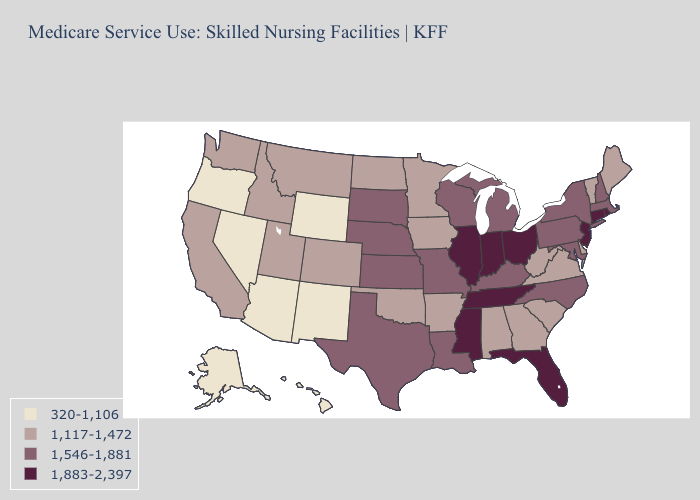What is the value of Missouri?
Be succinct. 1,546-1,881. Does Kansas have the lowest value in the USA?
Short answer required. No. Name the states that have a value in the range 320-1,106?
Write a very short answer. Alaska, Arizona, Hawaii, Nevada, New Mexico, Oregon, Wyoming. Name the states that have a value in the range 1,883-2,397?
Quick response, please. Connecticut, Florida, Illinois, Indiana, Mississippi, New Jersey, Ohio, Rhode Island, Tennessee. Name the states that have a value in the range 1,883-2,397?
Short answer required. Connecticut, Florida, Illinois, Indiana, Mississippi, New Jersey, Ohio, Rhode Island, Tennessee. What is the value of Washington?
Answer briefly. 1,117-1,472. Name the states that have a value in the range 1,883-2,397?
Answer briefly. Connecticut, Florida, Illinois, Indiana, Mississippi, New Jersey, Ohio, Rhode Island, Tennessee. Does the first symbol in the legend represent the smallest category?
Give a very brief answer. Yes. Is the legend a continuous bar?
Short answer required. No. Name the states that have a value in the range 320-1,106?
Short answer required. Alaska, Arizona, Hawaii, Nevada, New Mexico, Oregon, Wyoming. What is the value of Wisconsin?
Answer briefly. 1,546-1,881. Does South Dakota have a higher value than Indiana?
Concise answer only. No. What is the highest value in the South ?
Be succinct. 1,883-2,397. Name the states that have a value in the range 1,883-2,397?
Be succinct. Connecticut, Florida, Illinois, Indiana, Mississippi, New Jersey, Ohio, Rhode Island, Tennessee. What is the lowest value in states that border Connecticut?
Keep it brief. 1,546-1,881. 